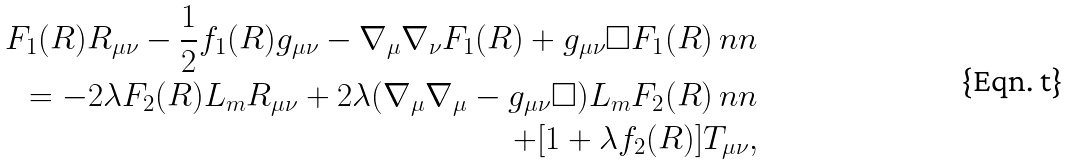Convert formula to latex. <formula><loc_0><loc_0><loc_500><loc_500>F _ { 1 } ( R ) R _ { \mu \nu } - \frac { 1 } { 2 } f _ { 1 } ( R ) g _ { \mu \nu } - \nabla _ { \mu } \nabla _ { \nu } F _ { 1 } ( R ) + g _ { \mu \nu } \Box F _ { 1 } ( R ) \ n n \\ = - 2 \lambda F _ { 2 } ( R ) L _ { m } R _ { \mu \nu } + 2 \lambda ( \nabla _ { \mu } \nabla _ { \mu } - g _ { \mu \nu } \Box ) L _ { m } F _ { 2 } ( R ) \ n n \\ + [ 1 + \lambda f _ { 2 } ( R ) ] T _ { \mu \nu } ,</formula> 